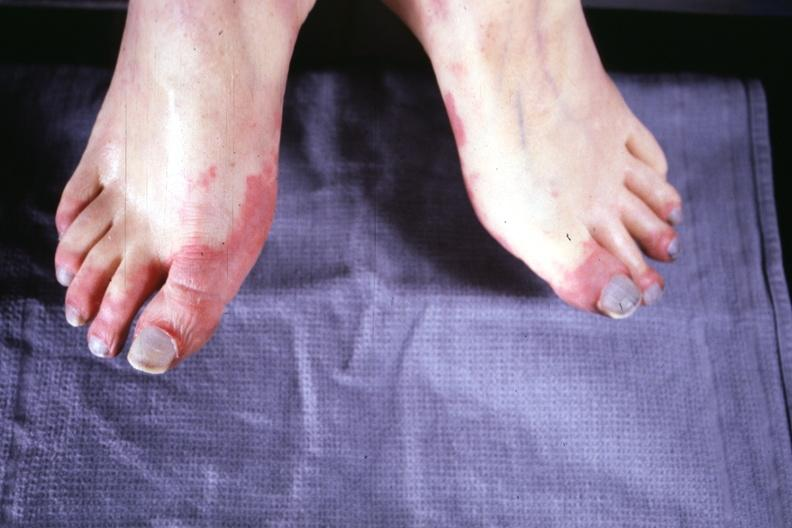does stillborn cord around neck show early lesion with erythematous appearance?
Answer the question using a single word or phrase. No 